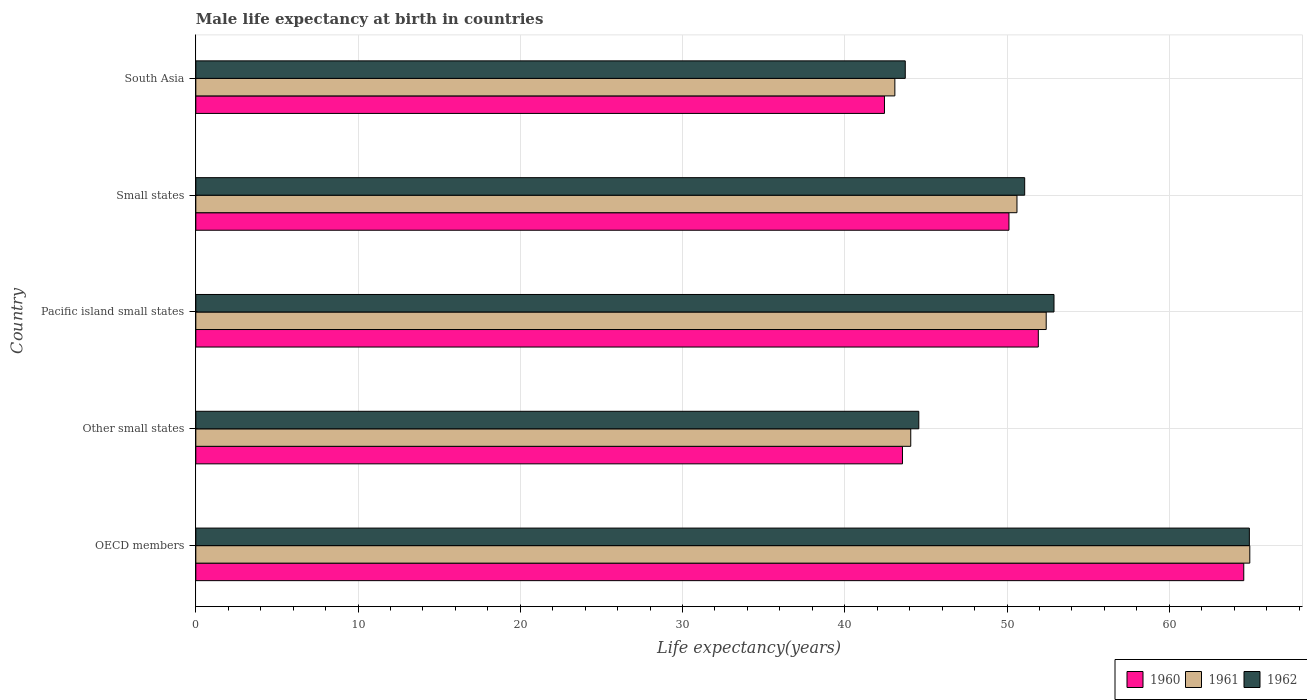How many different coloured bars are there?
Ensure brevity in your answer.  3. Are the number of bars per tick equal to the number of legend labels?
Provide a succinct answer. Yes. Are the number of bars on each tick of the Y-axis equal?
Provide a short and direct response. Yes. What is the label of the 5th group of bars from the top?
Your answer should be very brief. OECD members. In how many cases, is the number of bars for a given country not equal to the number of legend labels?
Offer a terse response. 0. What is the male life expectancy at birth in 1960 in Small states?
Provide a short and direct response. 50.12. Across all countries, what is the maximum male life expectancy at birth in 1962?
Your response must be concise. 64.94. Across all countries, what is the minimum male life expectancy at birth in 1960?
Provide a short and direct response. 42.45. In which country was the male life expectancy at birth in 1962 maximum?
Make the answer very short. OECD members. In which country was the male life expectancy at birth in 1960 minimum?
Give a very brief answer. South Asia. What is the total male life expectancy at birth in 1961 in the graph?
Give a very brief answer. 255.14. What is the difference between the male life expectancy at birth in 1960 in Other small states and that in Small states?
Your answer should be compact. -6.56. What is the difference between the male life expectancy at birth in 1962 in South Asia and the male life expectancy at birth in 1961 in OECD members?
Offer a terse response. -21.24. What is the average male life expectancy at birth in 1961 per country?
Your answer should be compact. 51.03. What is the difference between the male life expectancy at birth in 1962 and male life expectancy at birth in 1961 in OECD members?
Make the answer very short. -0.03. In how many countries, is the male life expectancy at birth in 1962 greater than 54 years?
Provide a succinct answer. 1. What is the ratio of the male life expectancy at birth in 1961 in OECD members to that in South Asia?
Give a very brief answer. 1.51. Is the difference between the male life expectancy at birth in 1962 in Other small states and Small states greater than the difference between the male life expectancy at birth in 1961 in Other small states and Small states?
Your answer should be compact. Yes. What is the difference between the highest and the second highest male life expectancy at birth in 1961?
Your answer should be very brief. 12.55. What is the difference between the highest and the lowest male life expectancy at birth in 1962?
Your answer should be very brief. 21.21. In how many countries, is the male life expectancy at birth in 1960 greater than the average male life expectancy at birth in 1960 taken over all countries?
Make the answer very short. 2. Is the sum of the male life expectancy at birth in 1960 in OECD members and South Asia greater than the maximum male life expectancy at birth in 1962 across all countries?
Ensure brevity in your answer.  Yes. What does the 2nd bar from the bottom in Other small states represents?
Your answer should be very brief. 1961. Are all the bars in the graph horizontal?
Offer a very short reply. Yes. Are the values on the major ticks of X-axis written in scientific E-notation?
Offer a terse response. No. Does the graph contain any zero values?
Provide a succinct answer. No. Where does the legend appear in the graph?
Offer a very short reply. Bottom right. What is the title of the graph?
Offer a very short reply. Male life expectancy at birth in countries. What is the label or title of the X-axis?
Provide a succinct answer. Life expectancy(years). What is the Life expectancy(years) in 1960 in OECD members?
Provide a short and direct response. 64.59. What is the Life expectancy(years) of 1961 in OECD members?
Provide a succinct answer. 64.96. What is the Life expectancy(years) of 1962 in OECD members?
Keep it short and to the point. 64.94. What is the Life expectancy(years) of 1960 in Other small states?
Provide a succinct answer. 43.56. What is the Life expectancy(years) in 1961 in Other small states?
Your response must be concise. 44.07. What is the Life expectancy(years) of 1962 in Other small states?
Give a very brief answer. 44.56. What is the Life expectancy(years) in 1960 in Pacific island small states?
Your answer should be very brief. 51.93. What is the Life expectancy(years) in 1961 in Pacific island small states?
Keep it short and to the point. 52.41. What is the Life expectancy(years) in 1962 in Pacific island small states?
Ensure brevity in your answer.  52.9. What is the Life expectancy(years) in 1960 in Small states?
Your answer should be compact. 50.12. What is the Life expectancy(years) of 1961 in Small states?
Give a very brief answer. 50.61. What is the Life expectancy(years) of 1962 in Small states?
Offer a terse response. 51.09. What is the Life expectancy(years) in 1960 in South Asia?
Provide a succinct answer. 42.45. What is the Life expectancy(years) of 1961 in South Asia?
Offer a very short reply. 43.09. What is the Life expectancy(years) in 1962 in South Asia?
Offer a very short reply. 43.73. Across all countries, what is the maximum Life expectancy(years) in 1960?
Ensure brevity in your answer.  64.59. Across all countries, what is the maximum Life expectancy(years) of 1961?
Offer a very short reply. 64.96. Across all countries, what is the maximum Life expectancy(years) of 1962?
Make the answer very short. 64.94. Across all countries, what is the minimum Life expectancy(years) of 1960?
Make the answer very short. 42.45. Across all countries, what is the minimum Life expectancy(years) in 1961?
Offer a terse response. 43.09. Across all countries, what is the minimum Life expectancy(years) in 1962?
Your answer should be compact. 43.73. What is the total Life expectancy(years) in 1960 in the graph?
Your response must be concise. 252.64. What is the total Life expectancy(years) of 1961 in the graph?
Provide a short and direct response. 255.14. What is the total Life expectancy(years) in 1962 in the graph?
Your answer should be very brief. 257.21. What is the difference between the Life expectancy(years) of 1960 in OECD members and that in Other small states?
Your response must be concise. 21.04. What is the difference between the Life expectancy(years) in 1961 in OECD members and that in Other small states?
Ensure brevity in your answer.  20.9. What is the difference between the Life expectancy(years) of 1962 in OECD members and that in Other small states?
Ensure brevity in your answer.  20.38. What is the difference between the Life expectancy(years) in 1960 in OECD members and that in Pacific island small states?
Provide a short and direct response. 12.66. What is the difference between the Life expectancy(years) in 1961 in OECD members and that in Pacific island small states?
Your response must be concise. 12.55. What is the difference between the Life expectancy(years) of 1962 in OECD members and that in Pacific island small states?
Ensure brevity in your answer.  12.04. What is the difference between the Life expectancy(years) in 1960 in OECD members and that in Small states?
Your answer should be very brief. 14.47. What is the difference between the Life expectancy(years) of 1961 in OECD members and that in Small states?
Ensure brevity in your answer.  14.35. What is the difference between the Life expectancy(years) of 1962 in OECD members and that in Small states?
Keep it short and to the point. 13.85. What is the difference between the Life expectancy(years) in 1960 in OECD members and that in South Asia?
Your answer should be compact. 22.15. What is the difference between the Life expectancy(years) of 1961 in OECD members and that in South Asia?
Provide a short and direct response. 21.88. What is the difference between the Life expectancy(years) in 1962 in OECD members and that in South Asia?
Your answer should be very brief. 21.21. What is the difference between the Life expectancy(years) in 1960 in Other small states and that in Pacific island small states?
Give a very brief answer. -8.37. What is the difference between the Life expectancy(years) in 1961 in Other small states and that in Pacific island small states?
Your response must be concise. -8.35. What is the difference between the Life expectancy(years) of 1962 in Other small states and that in Pacific island small states?
Offer a terse response. -8.33. What is the difference between the Life expectancy(years) of 1960 in Other small states and that in Small states?
Provide a succinct answer. -6.56. What is the difference between the Life expectancy(years) of 1961 in Other small states and that in Small states?
Your response must be concise. -6.55. What is the difference between the Life expectancy(years) of 1962 in Other small states and that in Small states?
Your response must be concise. -6.53. What is the difference between the Life expectancy(years) of 1960 in Other small states and that in South Asia?
Your answer should be compact. 1.11. What is the difference between the Life expectancy(years) in 1961 in Other small states and that in South Asia?
Keep it short and to the point. 0.98. What is the difference between the Life expectancy(years) in 1962 in Other small states and that in South Asia?
Provide a short and direct response. 0.83. What is the difference between the Life expectancy(years) in 1960 in Pacific island small states and that in Small states?
Make the answer very short. 1.81. What is the difference between the Life expectancy(years) of 1961 in Pacific island small states and that in Small states?
Provide a succinct answer. 1.8. What is the difference between the Life expectancy(years) in 1962 in Pacific island small states and that in Small states?
Offer a terse response. 1.81. What is the difference between the Life expectancy(years) in 1960 in Pacific island small states and that in South Asia?
Offer a terse response. 9.48. What is the difference between the Life expectancy(years) in 1961 in Pacific island small states and that in South Asia?
Make the answer very short. 9.33. What is the difference between the Life expectancy(years) of 1962 in Pacific island small states and that in South Asia?
Give a very brief answer. 9.17. What is the difference between the Life expectancy(years) of 1960 in Small states and that in South Asia?
Your answer should be very brief. 7.67. What is the difference between the Life expectancy(years) of 1961 in Small states and that in South Asia?
Provide a succinct answer. 7.53. What is the difference between the Life expectancy(years) in 1962 in Small states and that in South Asia?
Your answer should be very brief. 7.36. What is the difference between the Life expectancy(years) in 1960 in OECD members and the Life expectancy(years) in 1961 in Other small states?
Make the answer very short. 20.53. What is the difference between the Life expectancy(years) of 1960 in OECD members and the Life expectancy(years) of 1962 in Other small states?
Provide a succinct answer. 20.03. What is the difference between the Life expectancy(years) of 1961 in OECD members and the Life expectancy(years) of 1962 in Other small states?
Give a very brief answer. 20.4. What is the difference between the Life expectancy(years) in 1960 in OECD members and the Life expectancy(years) in 1961 in Pacific island small states?
Your answer should be very brief. 12.18. What is the difference between the Life expectancy(years) in 1960 in OECD members and the Life expectancy(years) in 1962 in Pacific island small states?
Offer a very short reply. 11.7. What is the difference between the Life expectancy(years) of 1961 in OECD members and the Life expectancy(years) of 1962 in Pacific island small states?
Make the answer very short. 12.07. What is the difference between the Life expectancy(years) in 1960 in OECD members and the Life expectancy(years) in 1961 in Small states?
Your response must be concise. 13.98. What is the difference between the Life expectancy(years) in 1960 in OECD members and the Life expectancy(years) in 1962 in Small states?
Keep it short and to the point. 13.5. What is the difference between the Life expectancy(years) in 1961 in OECD members and the Life expectancy(years) in 1962 in Small states?
Offer a terse response. 13.88. What is the difference between the Life expectancy(years) of 1960 in OECD members and the Life expectancy(years) of 1961 in South Asia?
Your answer should be compact. 21.51. What is the difference between the Life expectancy(years) in 1960 in OECD members and the Life expectancy(years) in 1962 in South Asia?
Provide a short and direct response. 20.86. What is the difference between the Life expectancy(years) of 1961 in OECD members and the Life expectancy(years) of 1962 in South Asia?
Ensure brevity in your answer.  21.24. What is the difference between the Life expectancy(years) of 1960 in Other small states and the Life expectancy(years) of 1961 in Pacific island small states?
Your answer should be compact. -8.86. What is the difference between the Life expectancy(years) of 1960 in Other small states and the Life expectancy(years) of 1962 in Pacific island small states?
Give a very brief answer. -9.34. What is the difference between the Life expectancy(years) in 1961 in Other small states and the Life expectancy(years) in 1962 in Pacific island small states?
Offer a terse response. -8.83. What is the difference between the Life expectancy(years) of 1960 in Other small states and the Life expectancy(years) of 1961 in Small states?
Provide a succinct answer. -7.06. What is the difference between the Life expectancy(years) of 1960 in Other small states and the Life expectancy(years) of 1962 in Small states?
Make the answer very short. -7.53. What is the difference between the Life expectancy(years) of 1961 in Other small states and the Life expectancy(years) of 1962 in Small states?
Give a very brief answer. -7.02. What is the difference between the Life expectancy(years) in 1960 in Other small states and the Life expectancy(years) in 1961 in South Asia?
Give a very brief answer. 0.47. What is the difference between the Life expectancy(years) in 1960 in Other small states and the Life expectancy(years) in 1962 in South Asia?
Your response must be concise. -0.17. What is the difference between the Life expectancy(years) of 1961 in Other small states and the Life expectancy(years) of 1962 in South Asia?
Offer a terse response. 0.34. What is the difference between the Life expectancy(years) in 1960 in Pacific island small states and the Life expectancy(years) in 1961 in Small states?
Offer a terse response. 1.32. What is the difference between the Life expectancy(years) of 1960 in Pacific island small states and the Life expectancy(years) of 1962 in Small states?
Your answer should be very brief. 0.84. What is the difference between the Life expectancy(years) of 1961 in Pacific island small states and the Life expectancy(years) of 1962 in Small states?
Your answer should be compact. 1.33. What is the difference between the Life expectancy(years) in 1960 in Pacific island small states and the Life expectancy(years) in 1961 in South Asia?
Offer a terse response. 8.84. What is the difference between the Life expectancy(years) of 1960 in Pacific island small states and the Life expectancy(years) of 1962 in South Asia?
Offer a very short reply. 8.2. What is the difference between the Life expectancy(years) of 1961 in Pacific island small states and the Life expectancy(years) of 1962 in South Asia?
Offer a very short reply. 8.69. What is the difference between the Life expectancy(years) in 1960 in Small states and the Life expectancy(years) in 1961 in South Asia?
Ensure brevity in your answer.  7.03. What is the difference between the Life expectancy(years) in 1960 in Small states and the Life expectancy(years) in 1962 in South Asia?
Offer a terse response. 6.39. What is the difference between the Life expectancy(years) of 1961 in Small states and the Life expectancy(years) of 1962 in South Asia?
Provide a succinct answer. 6.89. What is the average Life expectancy(years) in 1960 per country?
Make the answer very short. 50.53. What is the average Life expectancy(years) of 1961 per country?
Your answer should be very brief. 51.03. What is the average Life expectancy(years) of 1962 per country?
Give a very brief answer. 51.44. What is the difference between the Life expectancy(years) of 1960 and Life expectancy(years) of 1961 in OECD members?
Offer a very short reply. -0.37. What is the difference between the Life expectancy(years) of 1960 and Life expectancy(years) of 1962 in OECD members?
Offer a very short reply. -0.34. What is the difference between the Life expectancy(years) in 1961 and Life expectancy(years) in 1962 in OECD members?
Offer a very short reply. 0.03. What is the difference between the Life expectancy(years) in 1960 and Life expectancy(years) in 1961 in Other small states?
Your response must be concise. -0.51. What is the difference between the Life expectancy(years) in 1960 and Life expectancy(years) in 1962 in Other small states?
Your answer should be very brief. -1.01. What is the difference between the Life expectancy(years) of 1961 and Life expectancy(years) of 1962 in Other small states?
Make the answer very short. -0.5. What is the difference between the Life expectancy(years) in 1960 and Life expectancy(years) in 1961 in Pacific island small states?
Offer a terse response. -0.49. What is the difference between the Life expectancy(years) of 1960 and Life expectancy(years) of 1962 in Pacific island small states?
Make the answer very short. -0.97. What is the difference between the Life expectancy(years) in 1961 and Life expectancy(years) in 1962 in Pacific island small states?
Your response must be concise. -0.48. What is the difference between the Life expectancy(years) in 1960 and Life expectancy(years) in 1961 in Small states?
Provide a succinct answer. -0.49. What is the difference between the Life expectancy(years) of 1960 and Life expectancy(years) of 1962 in Small states?
Provide a short and direct response. -0.97. What is the difference between the Life expectancy(years) of 1961 and Life expectancy(years) of 1962 in Small states?
Your answer should be very brief. -0.48. What is the difference between the Life expectancy(years) of 1960 and Life expectancy(years) of 1961 in South Asia?
Provide a succinct answer. -0.64. What is the difference between the Life expectancy(years) in 1960 and Life expectancy(years) in 1962 in South Asia?
Provide a succinct answer. -1.28. What is the difference between the Life expectancy(years) of 1961 and Life expectancy(years) of 1962 in South Asia?
Provide a succinct answer. -0.64. What is the ratio of the Life expectancy(years) in 1960 in OECD members to that in Other small states?
Provide a short and direct response. 1.48. What is the ratio of the Life expectancy(years) of 1961 in OECD members to that in Other small states?
Keep it short and to the point. 1.47. What is the ratio of the Life expectancy(years) in 1962 in OECD members to that in Other small states?
Give a very brief answer. 1.46. What is the ratio of the Life expectancy(years) in 1960 in OECD members to that in Pacific island small states?
Provide a short and direct response. 1.24. What is the ratio of the Life expectancy(years) of 1961 in OECD members to that in Pacific island small states?
Make the answer very short. 1.24. What is the ratio of the Life expectancy(years) in 1962 in OECD members to that in Pacific island small states?
Give a very brief answer. 1.23. What is the ratio of the Life expectancy(years) of 1960 in OECD members to that in Small states?
Offer a very short reply. 1.29. What is the ratio of the Life expectancy(years) in 1961 in OECD members to that in Small states?
Give a very brief answer. 1.28. What is the ratio of the Life expectancy(years) of 1962 in OECD members to that in Small states?
Offer a very short reply. 1.27. What is the ratio of the Life expectancy(years) in 1960 in OECD members to that in South Asia?
Your answer should be very brief. 1.52. What is the ratio of the Life expectancy(years) of 1961 in OECD members to that in South Asia?
Your answer should be compact. 1.51. What is the ratio of the Life expectancy(years) of 1962 in OECD members to that in South Asia?
Give a very brief answer. 1.49. What is the ratio of the Life expectancy(years) in 1960 in Other small states to that in Pacific island small states?
Your answer should be very brief. 0.84. What is the ratio of the Life expectancy(years) of 1961 in Other small states to that in Pacific island small states?
Make the answer very short. 0.84. What is the ratio of the Life expectancy(years) in 1962 in Other small states to that in Pacific island small states?
Keep it short and to the point. 0.84. What is the ratio of the Life expectancy(years) in 1960 in Other small states to that in Small states?
Ensure brevity in your answer.  0.87. What is the ratio of the Life expectancy(years) in 1961 in Other small states to that in Small states?
Offer a terse response. 0.87. What is the ratio of the Life expectancy(years) of 1962 in Other small states to that in Small states?
Your answer should be compact. 0.87. What is the ratio of the Life expectancy(years) of 1960 in Other small states to that in South Asia?
Ensure brevity in your answer.  1.03. What is the ratio of the Life expectancy(years) in 1961 in Other small states to that in South Asia?
Offer a terse response. 1.02. What is the ratio of the Life expectancy(years) in 1962 in Other small states to that in South Asia?
Ensure brevity in your answer.  1.02. What is the ratio of the Life expectancy(years) of 1960 in Pacific island small states to that in Small states?
Keep it short and to the point. 1.04. What is the ratio of the Life expectancy(years) in 1961 in Pacific island small states to that in Small states?
Your answer should be very brief. 1.04. What is the ratio of the Life expectancy(years) of 1962 in Pacific island small states to that in Small states?
Keep it short and to the point. 1.04. What is the ratio of the Life expectancy(years) in 1960 in Pacific island small states to that in South Asia?
Ensure brevity in your answer.  1.22. What is the ratio of the Life expectancy(years) in 1961 in Pacific island small states to that in South Asia?
Offer a very short reply. 1.22. What is the ratio of the Life expectancy(years) of 1962 in Pacific island small states to that in South Asia?
Ensure brevity in your answer.  1.21. What is the ratio of the Life expectancy(years) in 1960 in Small states to that in South Asia?
Offer a terse response. 1.18. What is the ratio of the Life expectancy(years) in 1961 in Small states to that in South Asia?
Provide a succinct answer. 1.17. What is the ratio of the Life expectancy(years) in 1962 in Small states to that in South Asia?
Make the answer very short. 1.17. What is the difference between the highest and the second highest Life expectancy(years) of 1960?
Keep it short and to the point. 12.66. What is the difference between the highest and the second highest Life expectancy(years) of 1961?
Offer a terse response. 12.55. What is the difference between the highest and the second highest Life expectancy(years) of 1962?
Make the answer very short. 12.04. What is the difference between the highest and the lowest Life expectancy(years) of 1960?
Keep it short and to the point. 22.15. What is the difference between the highest and the lowest Life expectancy(years) in 1961?
Ensure brevity in your answer.  21.88. What is the difference between the highest and the lowest Life expectancy(years) of 1962?
Provide a short and direct response. 21.21. 